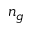<formula> <loc_0><loc_0><loc_500><loc_500>n _ { g }</formula> 